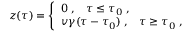<formula> <loc_0><loc_0><loc_500><loc_500>z ( \tau ) = \left \{ \begin{array} { l } { { 0 \, , \, \tau \leq \tau _ { 0 } \, , } } \\ { { v \gamma ( \tau - \tau _ { 0 } ) \, , \, \tau \geq \tau _ { 0 } \, , } } \end{array}</formula> 